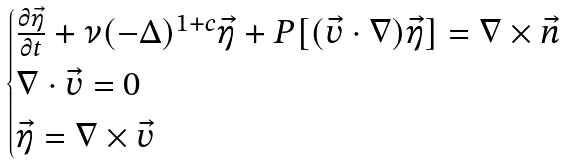<formula> <loc_0><loc_0><loc_500><loc_500>\begin{cases} \frac { \partial \vec { \eta } } { \partial t } + \nu ( - \Delta ) ^ { 1 + c } \vec { \eta } + P [ ( \vec { v } \cdot \nabla ) \vec { \eta } ] = \nabla \times \vec { n } \\ \nabla \cdot \vec { v } = 0 \\ \vec { \eta } = \nabla \times \vec { v } \end{cases}</formula> 